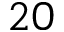<formula> <loc_0><loc_0><loc_500><loc_500>2 0</formula> 